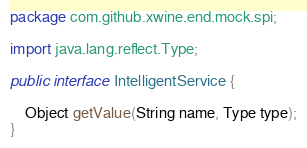<code> <loc_0><loc_0><loc_500><loc_500><_Java_>package com.github.xwine.end.mock.spi;

import java.lang.reflect.Type;

public interface IntelligentService {

    Object getValue(String name, Type type);
}
</code> 